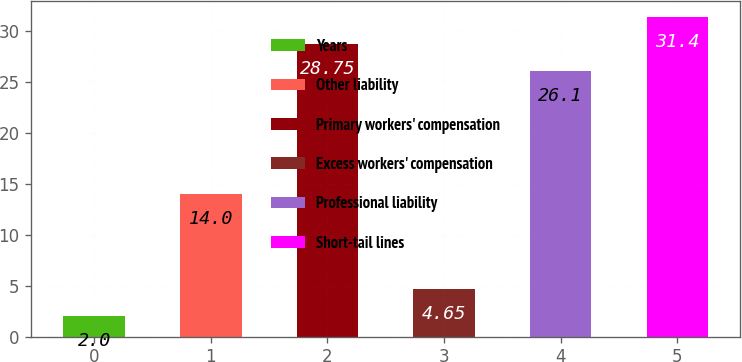<chart> <loc_0><loc_0><loc_500><loc_500><bar_chart><fcel>Years<fcel>Other liability<fcel>Primary workers' compensation<fcel>Excess workers' compensation<fcel>Professional liability<fcel>Short-tail lines<nl><fcel>2<fcel>14<fcel>28.75<fcel>4.65<fcel>26.1<fcel>31.4<nl></chart> 